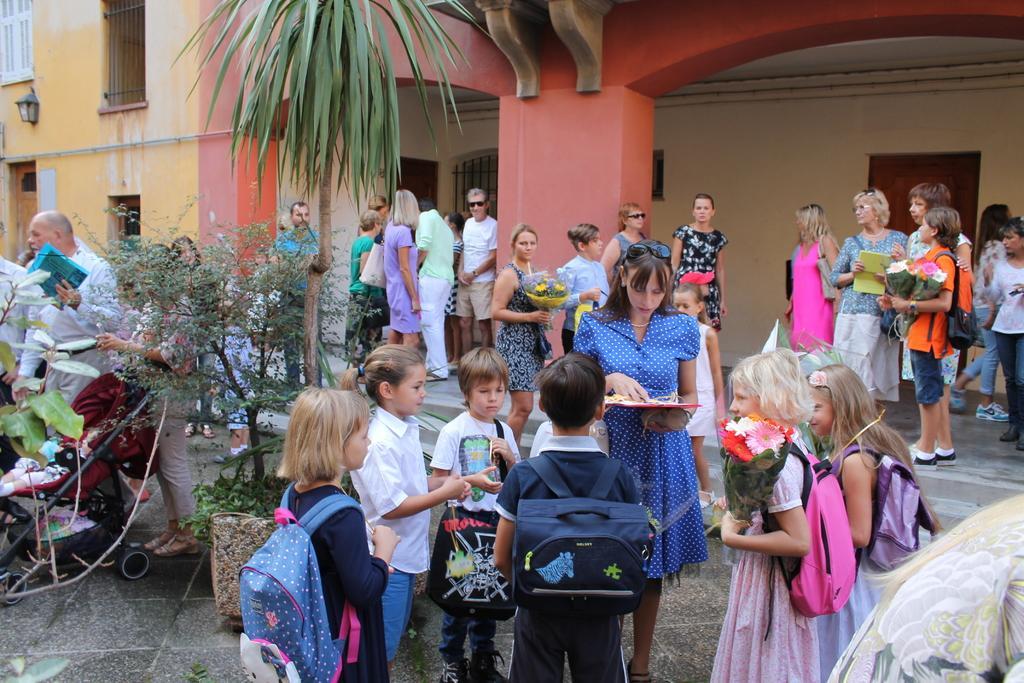Describe this image in one or two sentences. In this picture we can see a few kids wearing bags and standing on the path. There is a girl wearing a pink bag and holding a flower bouquet in her hands. We can see a woman holding an object. There is a person holding an object on the left side. Few people are visible at the back. There is a flower pot and a plant on the path. We can see some people are standing inside the building. There is a lantern and a few windows are seen in this building. 